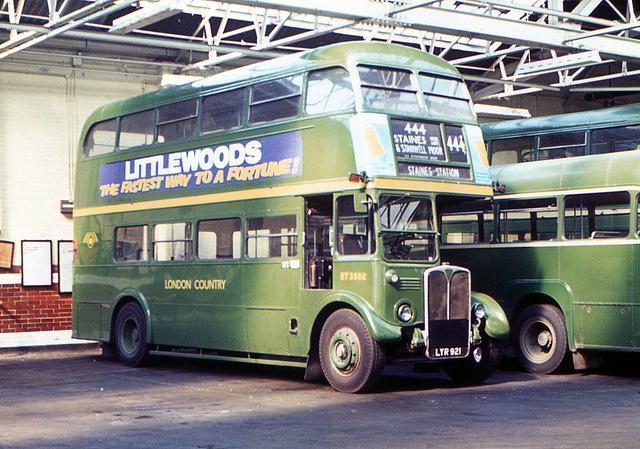How many buses are there?
Give a very brief answer. 2. 